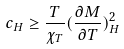Convert formula to latex. <formula><loc_0><loc_0><loc_500><loc_500>c _ { H } \geq \frac { T } { \chi _ { T } } ( \frac { \partial M } { \partial T } ) _ { H } ^ { 2 }</formula> 